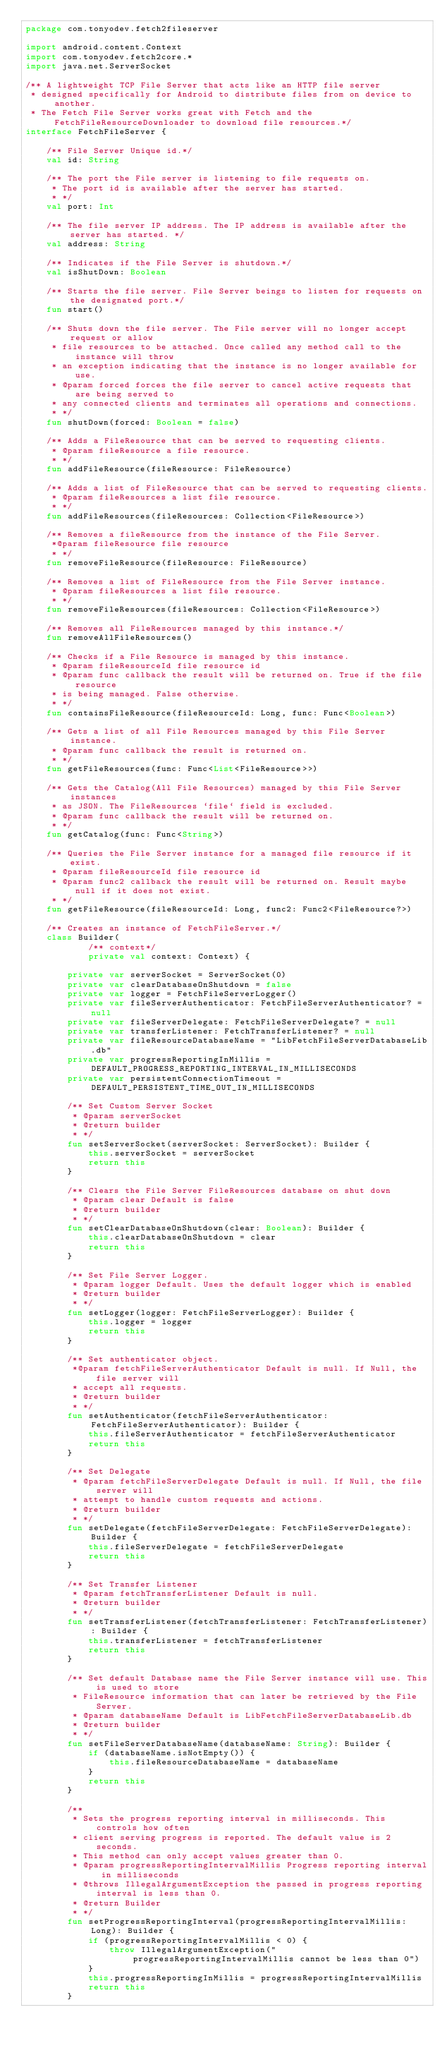Convert code to text. <code><loc_0><loc_0><loc_500><loc_500><_Kotlin_>package com.tonyodev.fetch2fileserver

import android.content.Context
import com.tonyodev.fetch2core.*
import java.net.ServerSocket

/** A lightweight TCP File Server that acts like an HTTP file server
 * designed specifically for Android to distribute files from on device to another.
 * The Fetch File Server works great with Fetch and the FetchFileResourceDownloader to download file resources.*/
interface FetchFileServer {

    /** File Server Unique id.*/
    val id: String

    /** The port the File server is listening to file requests on.
     * The port id is available after the server has started.
     * */
    val port: Int

    /** The file server IP address. The IP address is available after the server has started. */
    val address: String

    /** Indicates if the File Server is shutdown.*/
    val isShutDown: Boolean

    /** Starts the file server. File Server beings to listen for requests on the designated port.*/
    fun start()

    /** Shuts down the file server. The File server will no longer accept request or allow
     * file resources to be attached. Once called any method call to the instance will throw
     * an exception indicating that the instance is no longer available for use.
     * @param forced forces the file server to cancel active requests that are being served to
     * any connected clients and terminates all operations and connections.
     * */
    fun shutDown(forced: Boolean = false)

    /** Adds a FileResource that can be served to requesting clients.
     * @param fileResource a file resource.
     * */
    fun addFileResource(fileResource: FileResource)

    /** Adds a list of FileResource that can be served to requesting clients.
     * @param fileResources a list file resource.
     * */
    fun addFileResources(fileResources: Collection<FileResource>)

    /** Removes a fileResource from the instance of the File Server.
     *@param fileResource file resource
     * */
    fun removeFileResource(fileResource: FileResource)

    /** Removes a list of FileResource from the File Server instance.
     * @param fileResources a list file resource.
     * */
    fun removeFileResources(fileResources: Collection<FileResource>)

    /** Removes all FileResources managed by this instance.*/
    fun removeAllFileResources()

    /** Checks if a File Resource is managed by this instance.
     * @param fileResourceId file resource id
     * @param func callback the result will be returned on. True if the file resource
     * is being managed. False otherwise.
     * */
    fun containsFileResource(fileResourceId: Long, func: Func<Boolean>)

    /** Gets a list of all File Resources managed by this File Server instance.
     * @param func callback the result is returned on.
     * */
    fun getFileResources(func: Func<List<FileResource>>)

    /** Gets the Catalog(All File Resources) managed by this File Server instances
     * as JSON. The FileResources `file` field is excluded.
     * @param func callback the result will be returned on.
     * */
    fun getCatalog(func: Func<String>)

    /** Queries the File Server instance for a managed file resource if it exist.
     * @param fileResourceId file resource id
     * @param func2 callback the result will be returned on. Result maybe null if it does not exist.
     * */
    fun getFileResource(fileResourceId: Long, func2: Func2<FileResource?>)

    /** Creates an instance of FetchFileServer.*/
    class Builder(
            /** context*/
            private val context: Context) {

        private var serverSocket = ServerSocket(0)
        private var clearDatabaseOnShutdown = false
        private var logger = FetchFileServerLogger()
        private var fileServerAuthenticator: FetchFileServerAuthenticator? = null
        private var fileServerDelegate: FetchFileServerDelegate? = null
        private var transferListener: FetchTransferListener? = null
        private var fileResourceDatabaseName = "LibFetchFileServerDatabaseLib.db"
        private var progressReportingInMillis = DEFAULT_PROGRESS_REPORTING_INTERVAL_IN_MILLISECONDS
        private var persistentConnectionTimeout = DEFAULT_PERSISTENT_TIME_OUT_IN_MILLISECONDS

        /** Set Custom Server Socket
         * @param serverSocket
         * @return builder
         * */
        fun setServerSocket(serverSocket: ServerSocket): Builder {
            this.serverSocket = serverSocket
            return this
        }

        /** Clears the File Server FileResources database on shut down
         * @param clear Default is false
         * @return builder
         * */
        fun setClearDatabaseOnShutdown(clear: Boolean): Builder {
            this.clearDatabaseOnShutdown = clear
            return this
        }

        /** Set File Server Logger.
         * @param logger Default. Uses the default logger which is enabled
         * @return builder
         * */
        fun setLogger(logger: FetchFileServerLogger): Builder {
            this.logger = logger
            return this
        }

        /** Set authenticator object.
         *@param fetchFileServerAuthenticator Default is null. If Null, the file server will
         * accept all requests.
         * @return builder
         * */
        fun setAuthenticator(fetchFileServerAuthenticator: FetchFileServerAuthenticator): Builder {
            this.fileServerAuthenticator = fetchFileServerAuthenticator
            return this
        }

        /** Set Delegate
         * @param fetchFileServerDelegate Default is null. If Null, the file server will
         * attempt to handle custom requests and actions.
         * @return builder
         * */
        fun setDelegate(fetchFileServerDelegate: FetchFileServerDelegate): Builder {
            this.fileServerDelegate = fetchFileServerDelegate
            return this
        }

        /** Set Transfer Listener
         * @param fetchTransferListener Default is null.
         * @return builder
         * */
        fun setTransferListener(fetchTransferListener: FetchTransferListener): Builder {
            this.transferListener = fetchTransferListener
            return this
        }

        /** Set default Database name the File Server instance will use. This is used to store
         * FileResource information that can later be retrieved by the File Server.
         * @param databaseName Default is LibFetchFileServerDatabaseLib.db
         * @return builder
         * */
        fun setFileServerDatabaseName(databaseName: String): Builder {
            if (databaseName.isNotEmpty()) {
                this.fileResourceDatabaseName = databaseName
            }
            return this
        }

        /**
         * Sets the progress reporting interval in milliseconds. This controls how often
         * client serving progress is reported. The default value is 2 seconds.
         * This method can only accept values greater than 0.
         * @param progressReportingIntervalMillis Progress reporting interval in milliseconds
         * @throws IllegalArgumentException the passed in progress reporting interval is less than 0.
         * @return Builder
         * */
        fun setProgressReportingInterval(progressReportingIntervalMillis: Long): Builder {
            if (progressReportingIntervalMillis < 0) {
                throw IllegalArgumentException("progressReportingIntervalMillis cannot be less than 0")
            }
            this.progressReportingInMillis = progressReportingIntervalMillis
            return this
        }
</code> 